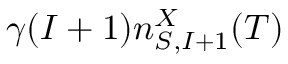Convert formula to latex. <formula><loc_0><loc_0><loc_500><loc_500>\gamma ( I + 1 ) n _ { S , I + 1 } ^ { X } ( T )</formula> 